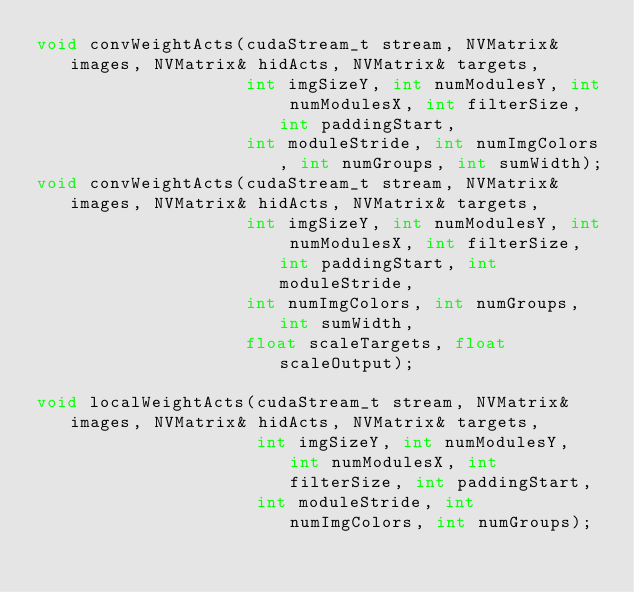Convert code to text. <code><loc_0><loc_0><loc_500><loc_500><_Cuda_>void convWeightActs(cudaStream_t stream, NVMatrix& images, NVMatrix& hidActs, NVMatrix& targets,
                    int imgSizeY, int numModulesY, int numModulesX, int filterSize, int paddingStart,
                    int moduleStride, int numImgColors, int numGroups, int sumWidth);
void convWeightActs(cudaStream_t stream, NVMatrix& images, NVMatrix& hidActs, NVMatrix& targets,
                    int imgSizeY, int numModulesY, int numModulesX, int filterSize, int paddingStart, int moduleStride,
                    int numImgColors, int numGroups, int sumWidth,
                    float scaleTargets, float scaleOutput);

void localWeightActs(cudaStream_t stream, NVMatrix& images, NVMatrix& hidActs, NVMatrix& targets,
                     int imgSizeY, int numModulesY, int numModulesX, int filterSize, int paddingStart,
                     int moduleStride, int numImgColors, int numGroups);
</code> 